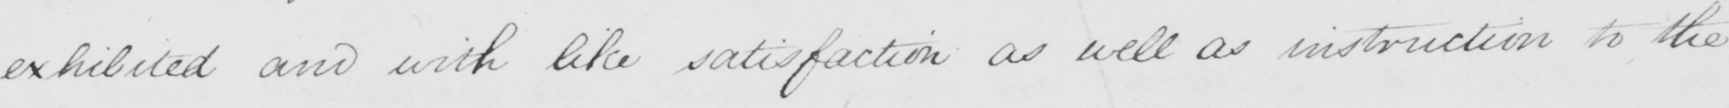Please provide the text content of this handwritten line. exhibited and with like satisfaction as well as instruction to the 